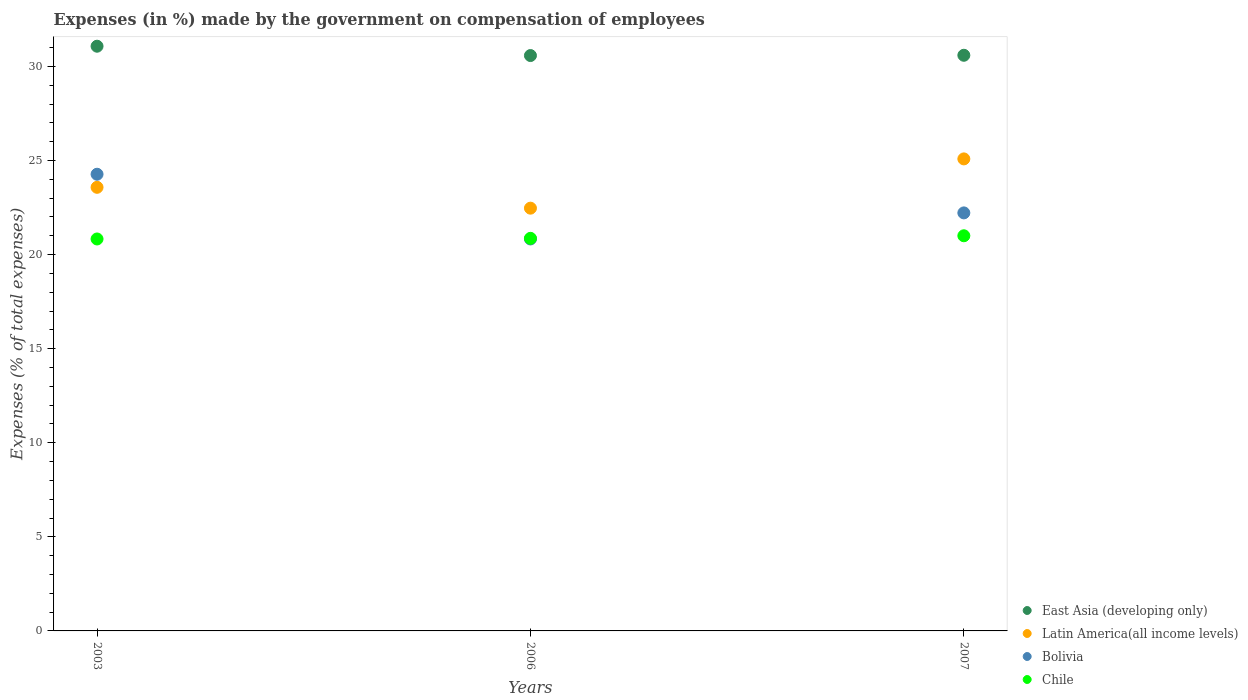What is the percentage of expenses made by the government on compensation of employees in Bolivia in 2007?
Your answer should be very brief. 22.22. Across all years, what is the maximum percentage of expenses made by the government on compensation of employees in Bolivia?
Provide a short and direct response. 24.27. Across all years, what is the minimum percentage of expenses made by the government on compensation of employees in Bolivia?
Provide a short and direct response. 20.83. In which year was the percentage of expenses made by the government on compensation of employees in Bolivia maximum?
Ensure brevity in your answer.  2003. What is the total percentage of expenses made by the government on compensation of employees in Chile in the graph?
Your answer should be compact. 62.69. What is the difference between the percentage of expenses made by the government on compensation of employees in Chile in 2006 and that in 2007?
Your answer should be compact. -0.14. What is the difference between the percentage of expenses made by the government on compensation of employees in Chile in 2006 and the percentage of expenses made by the government on compensation of employees in Bolivia in 2003?
Offer a very short reply. -3.41. What is the average percentage of expenses made by the government on compensation of employees in Chile per year?
Offer a terse response. 20.9. In the year 2003, what is the difference between the percentage of expenses made by the government on compensation of employees in Latin America(all income levels) and percentage of expenses made by the government on compensation of employees in East Asia (developing only)?
Ensure brevity in your answer.  -7.5. In how many years, is the percentage of expenses made by the government on compensation of employees in Bolivia greater than 12 %?
Your response must be concise. 3. What is the ratio of the percentage of expenses made by the government on compensation of employees in Chile in 2003 to that in 2007?
Make the answer very short. 0.99. Is the difference between the percentage of expenses made by the government on compensation of employees in Latin America(all income levels) in 2003 and 2006 greater than the difference between the percentage of expenses made by the government on compensation of employees in East Asia (developing only) in 2003 and 2006?
Ensure brevity in your answer.  Yes. What is the difference between the highest and the second highest percentage of expenses made by the government on compensation of employees in Bolivia?
Your answer should be very brief. 2.05. What is the difference between the highest and the lowest percentage of expenses made by the government on compensation of employees in East Asia (developing only)?
Provide a short and direct response. 0.5. In how many years, is the percentage of expenses made by the government on compensation of employees in East Asia (developing only) greater than the average percentage of expenses made by the government on compensation of employees in East Asia (developing only) taken over all years?
Offer a very short reply. 1. Is it the case that in every year, the sum of the percentage of expenses made by the government on compensation of employees in Latin America(all income levels) and percentage of expenses made by the government on compensation of employees in East Asia (developing only)  is greater than the percentage of expenses made by the government on compensation of employees in Bolivia?
Make the answer very short. Yes. How many years are there in the graph?
Make the answer very short. 3. What is the difference between two consecutive major ticks on the Y-axis?
Make the answer very short. 5. Where does the legend appear in the graph?
Give a very brief answer. Bottom right. How many legend labels are there?
Offer a very short reply. 4. How are the legend labels stacked?
Your answer should be very brief. Vertical. What is the title of the graph?
Ensure brevity in your answer.  Expenses (in %) made by the government on compensation of employees. Does "Rwanda" appear as one of the legend labels in the graph?
Your response must be concise. No. What is the label or title of the Y-axis?
Offer a very short reply. Expenses (% of total expenses). What is the Expenses (% of total expenses) in East Asia (developing only) in 2003?
Your response must be concise. 31.07. What is the Expenses (% of total expenses) in Latin America(all income levels) in 2003?
Give a very brief answer. 23.58. What is the Expenses (% of total expenses) of Bolivia in 2003?
Offer a very short reply. 24.27. What is the Expenses (% of total expenses) of Chile in 2003?
Offer a very short reply. 20.83. What is the Expenses (% of total expenses) of East Asia (developing only) in 2006?
Your response must be concise. 30.58. What is the Expenses (% of total expenses) of Latin America(all income levels) in 2006?
Your answer should be compact. 22.47. What is the Expenses (% of total expenses) of Bolivia in 2006?
Your response must be concise. 20.83. What is the Expenses (% of total expenses) in Chile in 2006?
Give a very brief answer. 20.86. What is the Expenses (% of total expenses) in East Asia (developing only) in 2007?
Make the answer very short. 30.59. What is the Expenses (% of total expenses) in Latin America(all income levels) in 2007?
Your answer should be compact. 25.09. What is the Expenses (% of total expenses) in Bolivia in 2007?
Your answer should be very brief. 22.22. What is the Expenses (% of total expenses) of Chile in 2007?
Offer a terse response. 21. Across all years, what is the maximum Expenses (% of total expenses) of East Asia (developing only)?
Make the answer very short. 31.07. Across all years, what is the maximum Expenses (% of total expenses) in Latin America(all income levels)?
Make the answer very short. 25.09. Across all years, what is the maximum Expenses (% of total expenses) in Bolivia?
Offer a very short reply. 24.27. Across all years, what is the maximum Expenses (% of total expenses) of Chile?
Ensure brevity in your answer.  21. Across all years, what is the minimum Expenses (% of total expenses) of East Asia (developing only)?
Provide a succinct answer. 30.58. Across all years, what is the minimum Expenses (% of total expenses) of Latin America(all income levels)?
Ensure brevity in your answer.  22.47. Across all years, what is the minimum Expenses (% of total expenses) of Bolivia?
Keep it short and to the point. 20.83. Across all years, what is the minimum Expenses (% of total expenses) of Chile?
Keep it short and to the point. 20.83. What is the total Expenses (% of total expenses) of East Asia (developing only) in the graph?
Ensure brevity in your answer.  92.24. What is the total Expenses (% of total expenses) in Latin America(all income levels) in the graph?
Provide a short and direct response. 71.13. What is the total Expenses (% of total expenses) of Bolivia in the graph?
Give a very brief answer. 67.32. What is the total Expenses (% of total expenses) in Chile in the graph?
Offer a very short reply. 62.69. What is the difference between the Expenses (% of total expenses) in East Asia (developing only) in 2003 and that in 2006?
Ensure brevity in your answer.  0.5. What is the difference between the Expenses (% of total expenses) of Latin America(all income levels) in 2003 and that in 2006?
Provide a short and direct response. 1.11. What is the difference between the Expenses (% of total expenses) in Bolivia in 2003 and that in 2006?
Offer a very short reply. 3.44. What is the difference between the Expenses (% of total expenses) in Chile in 2003 and that in 2006?
Give a very brief answer. -0.03. What is the difference between the Expenses (% of total expenses) of East Asia (developing only) in 2003 and that in 2007?
Your response must be concise. 0.48. What is the difference between the Expenses (% of total expenses) in Latin America(all income levels) in 2003 and that in 2007?
Offer a very short reply. -1.51. What is the difference between the Expenses (% of total expenses) in Bolivia in 2003 and that in 2007?
Keep it short and to the point. 2.05. What is the difference between the Expenses (% of total expenses) of Chile in 2003 and that in 2007?
Offer a terse response. -0.17. What is the difference between the Expenses (% of total expenses) in East Asia (developing only) in 2006 and that in 2007?
Give a very brief answer. -0.01. What is the difference between the Expenses (% of total expenses) in Latin America(all income levels) in 2006 and that in 2007?
Give a very brief answer. -2.62. What is the difference between the Expenses (% of total expenses) in Bolivia in 2006 and that in 2007?
Offer a terse response. -1.39. What is the difference between the Expenses (% of total expenses) in Chile in 2006 and that in 2007?
Your answer should be very brief. -0.14. What is the difference between the Expenses (% of total expenses) in East Asia (developing only) in 2003 and the Expenses (% of total expenses) in Latin America(all income levels) in 2006?
Keep it short and to the point. 8.61. What is the difference between the Expenses (% of total expenses) in East Asia (developing only) in 2003 and the Expenses (% of total expenses) in Bolivia in 2006?
Your response must be concise. 10.24. What is the difference between the Expenses (% of total expenses) of East Asia (developing only) in 2003 and the Expenses (% of total expenses) of Chile in 2006?
Your answer should be very brief. 10.21. What is the difference between the Expenses (% of total expenses) of Latin America(all income levels) in 2003 and the Expenses (% of total expenses) of Bolivia in 2006?
Give a very brief answer. 2.75. What is the difference between the Expenses (% of total expenses) of Latin America(all income levels) in 2003 and the Expenses (% of total expenses) of Chile in 2006?
Make the answer very short. 2.71. What is the difference between the Expenses (% of total expenses) in Bolivia in 2003 and the Expenses (% of total expenses) in Chile in 2006?
Provide a short and direct response. 3.41. What is the difference between the Expenses (% of total expenses) in East Asia (developing only) in 2003 and the Expenses (% of total expenses) in Latin America(all income levels) in 2007?
Give a very brief answer. 5.99. What is the difference between the Expenses (% of total expenses) of East Asia (developing only) in 2003 and the Expenses (% of total expenses) of Bolivia in 2007?
Provide a short and direct response. 8.86. What is the difference between the Expenses (% of total expenses) in East Asia (developing only) in 2003 and the Expenses (% of total expenses) in Chile in 2007?
Your answer should be very brief. 10.07. What is the difference between the Expenses (% of total expenses) in Latin America(all income levels) in 2003 and the Expenses (% of total expenses) in Bolivia in 2007?
Provide a short and direct response. 1.36. What is the difference between the Expenses (% of total expenses) of Latin America(all income levels) in 2003 and the Expenses (% of total expenses) of Chile in 2007?
Offer a terse response. 2.58. What is the difference between the Expenses (% of total expenses) in Bolivia in 2003 and the Expenses (% of total expenses) in Chile in 2007?
Your response must be concise. 3.27. What is the difference between the Expenses (% of total expenses) of East Asia (developing only) in 2006 and the Expenses (% of total expenses) of Latin America(all income levels) in 2007?
Ensure brevity in your answer.  5.49. What is the difference between the Expenses (% of total expenses) of East Asia (developing only) in 2006 and the Expenses (% of total expenses) of Bolivia in 2007?
Offer a very short reply. 8.36. What is the difference between the Expenses (% of total expenses) of East Asia (developing only) in 2006 and the Expenses (% of total expenses) of Chile in 2007?
Give a very brief answer. 9.58. What is the difference between the Expenses (% of total expenses) of Latin America(all income levels) in 2006 and the Expenses (% of total expenses) of Bolivia in 2007?
Your response must be concise. 0.25. What is the difference between the Expenses (% of total expenses) in Latin America(all income levels) in 2006 and the Expenses (% of total expenses) in Chile in 2007?
Ensure brevity in your answer.  1.47. What is the difference between the Expenses (% of total expenses) in Bolivia in 2006 and the Expenses (% of total expenses) in Chile in 2007?
Your response must be concise. -0.17. What is the average Expenses (% of total expenses) of East Asia (developing only) per year?
Keep it short and to the point. 30.75. What is the average Expenses (% of total expenses) in Latin America(all income levels) per year?
Offer a terse response. 23.71. What is the average Expenses (% of total expenses) of Bolivia per year?
Ensure brevity in your answer.  22.44. What is the average Expenses (% of total expenses) of Chile per year?
Your answer should be compact. 20.9. In the year 2003, what is the difference between the Expenses (% of total expenses) of East Asia (developing only) and Expenses (% of total expenses) of Latin America(all income levels)?
Provide a short and direct response. 7.5. In the year 2003, what is the difference between the Expenses (% of total expenses) of East Asia (developing only) and Expenses (% of total expenses) of Bolivia?
Keep it short and to the point. 6.8. In the year 2003, what is the difference between the Expenses (% of total expenses) of East Asia (developing only) and Expenses (% of total expenses) of Chile?
Make the answer very short. 10.24. In the year 2003, what is the difference between the Expenses (% of total expenses) in Latin America(all income levels) and Expenses (% of total expenses) in Bolivia?
Give a very brief answer. -0.69. In the year 2003, what is the difference between the Expenses (% of total expenses) in Latin America(all income levels) and Expenses (% of total expenses) in Chile?
Make the answer very short. 2.75. In the year 2003, what is the difference between the Expenses (% of total expenses) of Bolivia and Expenses (% of total expenses) of Chile?
Offer a very short reply. 3.44. In the year 2006, what is the difference between the Expenses (% of total expenses) in East Asia (developing only) and Expenses (% of total expenses) in Latin America(all income levels)?
Your answer should be compact. 8.11. In the year 2006, what is the difference between the Expenses (% of total expenses) in East Asia (developing only) and Expenses (% of total expenses) in Bolivia?
Ensure brevity in your answer.  9.75. In the year 2006, what is the difference between the Expenses (% of total expenses) of East Asia (developing only) and Expenses (% of total expenses) of Chile?
Offer a very short reply. 9.71. In the year 2006, what is the difference between the Expenses (% of total expenses) of Latin America(all income levels) and Expenses (% of total expenses) of Bolivia?
Provide a succinct answer. 1.64. In the year 2006, what is the difference between the Expenses (% of total expenses) of Latin America(all income levels) and Expenses (% of total expenses) of Chile?
Your response must be concise. 1.6. In the year 2006, what is the difference between the Expenses (% of total expenses) in Bolivia and Expenses (% of total expenses) in Chile?
Ensure brevity in your answer.  -0.03. In the year 2007, what is the difference between the Expenses (% of total expenses) in East Asia (developing only) and Expenses (% of total expenses) in Latin America(all income levels)?
Make the answer very short. 5.51. In the year 2007, what is the difference between the Expenses (% of total expenses) of East Asia (developing only) and Expenses (% of total expenses) of Bolivia?
Your response must be concise. 8.38. In the year 2007, what is the difference between the Expenses (% of total expenses) of East Asia (developing only) and Expenses (% of total expenses) of Chile?
Your answer should be compact. 9.59. In the year 2007, what is the difference between the Expenses (% of total expenses) of Latin America(all income levels) and Expenses (% of total expenses) of Bolivia?
Keep it short and to the point. 2.87. In the year 2007, what is the difference between the Expenses (% of total expenses) of Latin America(all income levels) and Expenses (% of total expenses) of Chile?
Your answer should be compact. 4.09. In the year 2007, what is the difference between the Expenses (% of total expenses) of Bolivia and Expenses (% of total expenses) of Chile?
Ensure brevity in your answer.  1.22. What is the ratio of the Expenses (% of total expenses) of East Asia (developing only) in 2003 to that in 2006?
Provide a short and direct response. 1.02. What is the ratio of the Expenses (% of total expenses) of Latin America(all income levels) in 2003 to that in 2006?
Provide a short and direct response. 1.05. What is the ratio of the Expenses (% of total expenses) in Bolivia in 2003 to that in 2006?
Offer a terse response. 1.17. What is the ratio of the Expenses (% of total expenses) in East Asia (developing only) in 2003 to that in 2007?
Ensure brevity in your answer.  1.02. What is the ratio of the Expenses (% of total expenses) of Latin America(all income levels) in 2003 to that in 2007?
Provide a succinct answer. 0.94. What is the ratio of the Expenses (% of total expenses) of Bolivia in 2003 to that in 2007?
Offer a very short reply. 1.09. What is the ratio of the Expenses (% of total expenses) of Chile in 2003 to that in 2007?
Keep it short and to the point. 0.99. What is the ratio of the Expenses (% of total expenses) in Latin America(all income levels) in 2006 to that in 2007?
Your response must be concise. 0.9. What is the ratio of the Expenses (% of total expenses) in Bolivia in 2006 to that in 2007?
Give a very brief answer. 0.94. What is the difference between the highest and the second highest Expenses (% of total expenses) of East Asia (developing only)?
Provide a short and direct response. 0.48. What is the difference between the highest and the second highest Expenses (% of total expenses) in Latin America(all income levels)?
Give a very brief answer. 1.51. What is the difference between the highest and the second highest Expenses (% of total expenses) in Bolivia?
Keep it short and to the point. 2.05. What is the difference between the highest and the second highest Expenses (% of total expenses) of Chile?
Provide a short and direct response. 0.14. What is the difference between the highest and the lowest Expenses (% of total expenses) in East Asia (developing only)?
Your answer should be very brief. 0.5. What is the difference between the highest and the lowest Expenses (% of total expenses) in Latin America(all income levels)?
Keep it short and to the point. 2.62. What is the difference between the highest and the lowest Expenses (% of total expenses) in Bolivia?
Make the answer very short. 3.44. What is the difference between the highest and the lowest Expenses (% of total expenses) of Chile?
Your answer should be compact. 0.17. 